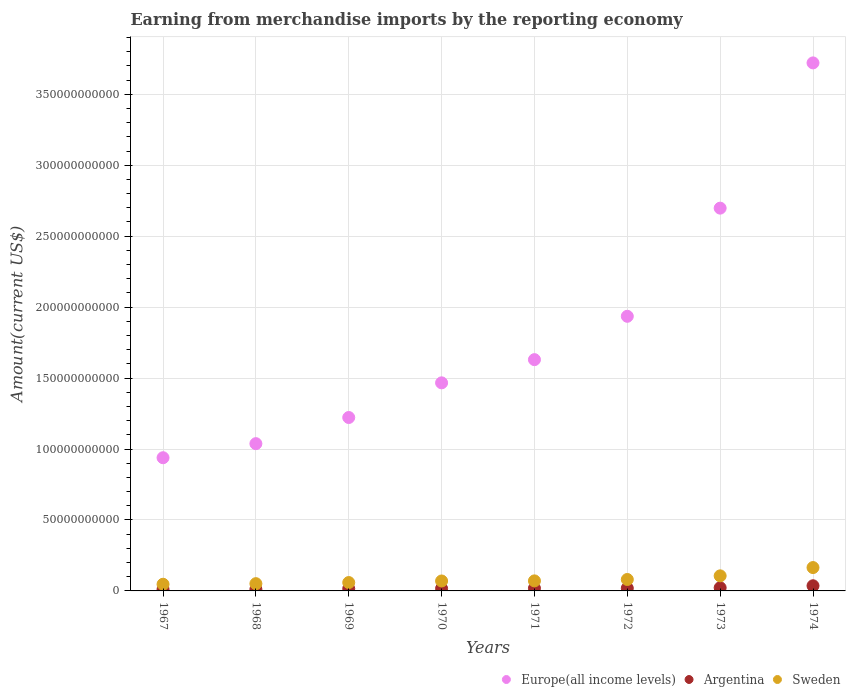Is the number of dotlines equal to the number of legend labels?
Your response must be concise. Yes. What is the amount earned from merchandise imports in Argentina in 1973?
Ensure brevity in your answer.  2.24e+09. Across all years, what is the maximum amount earned from merchandise imports in Europe(all income levels)?
Your response must be concise. 3.72e+11. Across all years, what is the minimum amount earned from merchandise imports in Europe(all income levels)?
Offer a terse response. 9.39e+1. In which year was the amount earned from merchandise imports in Sweden maximum?
Give a very brief answer. 1974. In which year was the amount earned from merchandise imports in Europe(all income levels) minimum?
Offer a terse response. 1967. What is the total amount earned from merchandise imports in Sweden in the graph?
Provide a short and direct response. 6.49e+1. What is the difference between the amount earned from merchandise imports in Sweden in 1967 and that in 1969?
Give a very brief answer. -1.21e+09. What is the difference between the amount earned from merchandise imports in Sweden in 1967 and the amount earned from merchandise imports in Europe(all income levels) in 1974?
Your answer should be very brief. -3.67e+11. What is the average amount earned from merchandise imports in Sweden per year?
Offer a very short reply. 8.12e+09. In the year 1970, what is the difference between the amount earned from merchandise imports in Sweden and amount earned from merchandise imports in Argentina?
Give a very brief answer. 5.32e+09. In how many years, is the amount earned from merchandise imports in Europe(all income levels) greater than 110000000000 US$?
Keep it short and to the point. 6. What is the ratio of the amount earned from merchandise imports in Europe(all income levels) in 1973 to that in 1974?
Offer a very short reply. 0.72. Is the difference between the amount earned from merchandise imports in Sweden in 1970 and 1973 greater than the difference between the amount earned from merchandise imports in Argentina in 1970 and 1973?
Provide a short and direct response. No. What is the difference between the highest and the second highest amount earned from merchandise imports in Sweden?
Make the answer very short. 5.83e+09. What is the difference between the highest and the lowest amount earned from merchandise imports in Sweden?
Your answer should be compact. 1.18e+1. In how many years, is the amount earned from merchandise imports in Sweden greater than the average amount earned from merchandise imports in Sweden taken over all years?
Give a very brief answer. 2. Is the sum of the amount earned from merchandise imports in Europe(all income levels) in 1970 and 1972 greater than the maximum amount earned from merchandise imports in Sweden across all years?
Provide a succinct answer. Yes. Is it the case that in every year, the sum of the amount earned from merchandise imports in Argentina and amount earned from merchandise imports in Europe(all income levels)  is greater than the amount earned from merchandise imports in Sweden?
Your answer should be compact. Yes. Is the amount earned from merchandise imports in Europe(all income levels) strictly less than the amount earned from merchandise imports in Sweden over the years?
Your answer should be very brief. No. How many dotlines are there?
Give a very brief answer. 3. How many years are there in the graph?
Provide a short and direct response. 8. Does the graph contain any zero values?
Give a very brief answer. No. Does the graph contain grids?
Your answer should be very brief. Yes. Where does the legend appear in the graph?
Your answer should be very brief. Bottom right. How are the legend labels stacked?
Keep it short and to the point. Horizontal. What is the title of the graph?
Keep it short and to the point. Earning from merchandise imports by the reporting economy. What is the label or title of the Y-axis?
Your answer should be very brief. Amount(current US$). What is the Amount(current US$) in Europe(all income levels) in 1967?
Offer a very short reply. 9.39e+1. What is the Amount(current US$) in Argentina in 1967?
Offer a terse response. 1.10e+09. What is the Amount(current US$) in Sweden in 1967?
Keep it short and to the point. 4.70e+09. What is the Amount(current US$) in Europe(all income levels) in 1968?
Make the answer very short. 1.04e+11. What is the Amount(current US$) in Argentina in 1968?
Provide a succinct answer. 1.17e+09. What is the Amount(current US$) in Sweden in 1968?
Ensure brevity in your answer.  5.12e+09. What is the Amount(current US$) in Europe(all income levels) in 1969?
Your answer should be compact. 1.22e+11. What is the Amount(current US$) of Argentina in 1969?
Provide a short and direct response. 1.58e+09. What is the Amount(current US$) of Sweden in 1969?
Your answer should be compact. 5.90e+09. What is the Amount(current US$) in Europe(all income levels) in 1970?
Ensure brevity in your answer.  1.47e+11. What is the Amount(current US$) in Argentina in 1970?
Offer a terse response. 1.68e+09. What is the Amount(current US$) in Sweden in 1970?
Your answer should be very brief. 7.01e+09. What is the Amount(current US$) in Europe(all income levels) in 1971?
Offer a very short reply. 1.63e+11. What is the Amount(current US$) in Argentina in 1971?
Ensure brevity in your answer.  1.87e+09. What is the Amount(current US$) in Sweden in 1971?
Offer a very short reply. 7.08e+09. What is the Amount(current US$) of Europe(all income levels) in 1972?
Keep it short and to the point. 1.94e+11. What is the Amount(current US$) of Argentina in 1972?
Provide a succinct answer. 1.90e+09. What is the Amount(current US$) in Sweden in 1972?
Your answer should be compact. 8.06e+09. What is the Amount(current US$) of Europe(all income levels) in 1973?
Your answer should be compact. 2.70e+11. What is the Amount(current US$) of Argentina in 1973?
Your answer should be very brief. 2.24e+09. What is the Amount(current US$) in Sweden in 1973?
Provide a succinct answer. 1.06e+1. What is the Amount(current US$) in Europe(all income levels) in 1974?
Make the answer very short. 3.72e+11. What is the Amount(current US$) of Argentina in 1974?
Ensure brevity in your answer.  3.64e+09. What is the Amount(current US$) of Sweden in 1974?
Provide a short and direct response. 1.65e+1. Across all years, what is the maximum Amount(current US$) of Europe(all income levels)?
Your answer should be compact. 3.72e+11. Across all years, what is the maximum Amount(current US$) of Argentina?
Offer a very short reply. 3.64e+09. Across all years, what is the maximum Amount(current US$) of Sweden?
Provide a succinct answer. 1.65e+1. Across all years, what is the minimum Amount(current US$) in Europe(all income levels)?
Your response must be concise. 9.39e+1. Across all years, what is the minimum Amount(current US$) of Argentina?
Your response must be concise. 1.10e+09. Across all years, what is the minimum Amount(current US$) in Sweden?
Your answer should be very brief. 4.70e+09. What is the total Amount(current US$) in Europe(all income levels) in the graph?
Offer a terse response. 1.46e+12. What is the total Amount(current US$) of Argentina in the graph?
Give a very brief answer. 1.52e+1. What is the total Amount(current US$) in Sweden in the graph?
Make the answer very short. 6.49e+1. What is the difference between the Amount(current US$) in Europe(all income levels) in 1967 and that in 1968?
Provide a short and direct response. -9.92e+09. What is the difference between the Amount(current US$) of Argentina in 1967 and that in 1968?
Keep it short and to the point. -7.40e+07. What is the difference between the Amount(current US$) in Sweden in 1967 and that in 1968?
Your answer should be very brief. -4.19e+08. What is the difference between the Amount(current US$) in Europe(all income levels) in 1967 and that in 1969?
Make the answer very short. -2.83e+1. What is the difference between the Amount(current US$) in Argentina in 1967 and that in 1969?
Provide a succinct answer. -4.81e+08. What is the difference between the Amount(current US$) of Sweden in 1967 and that in 1969?
Offer a very short reply. -1.21e+09. What is the difference between the Amount(current US$) in Europe(all income levels) in 1967 and that in 1970?
Provide a short and direct response. -5.28e+1. What is the difference between the Amount(current US$) in Argentina in 1967 and that in 1970?
Provide a succinct answer. -5.89e+08. What is the difference between the Amount(current US$) in Sweden in 1967 and that in 1970?
Give a very brief answer. -2.31e+09. What is the difference between the Amount(current US$) of Europe(all income levels) in 1967 and that in 1971?
Offer a terse response. -6.91e+1. What is the difference between the Amount(current US$) of Argentina in 1967 and that in 1971?
Your answer should be very brief. -7.74e+08. What is the difference between the Amount(current US$) of Sweden in 1967 and that in 1971?
Provide a succinct answer. -2.38e+09. What is the difference between the Amount(current US$) of Europe(all income levels) in 1967 and that in 1972?
Offer a very short reply. -9.97e+1. What is the difference between the Amount(current US$) in Argentina in 1967 and that in 1972?
Ensure brevity in your answer.  -8.09e+08. What is the difference between the Amount(current US$) of Sweden in 1967 and that in 1972?
Make the answer very short. -3.36e+09. What is the difference between the Amount(current US$) in Europe(all income levels) in 1967 and that in 1973?
Your answer should be very brief. -1.76e+11. What is the difference between the Amount(current US$) in Argentina in 1967 and that in 1973?
Keep it short and to the point. -1.15e+09. What is the difference between the Amount(current US$) in Sweden in 1967 and that in 1973?
Ensure brevity in your answer.  -5.93e+09. What is the difference between the Amount(current US$) in Europe(all income levels) in 1967 and that in 1974?
Offer a very short reply. -2.78e+11. What is the difference between the Amount(current US$) of Argentina in 1967 and that in 1974?
Offer a terse response. -2.54e+09. What is the difference between the Amount(current US$) of Sweden in 1967 and that in 1974?
Offer a terse response. -1.18e+1. What is the difference between the Amount(current US$) of Europe(all income levels) in 1968 and that in 1969?
Offer a terse response. -1.84e+1. What is the difference between the Amount(current US$) in Argentina in 1968 and that in 1969?
Give a very brief answer. -4.07e+08. What is the difference between the Amount(current US$) in Sweden in 1968 and that in 1969?
Keep it short and to the point. -7.86e+08. What is the difference between the Amount(current US$) in Europe(all income levels) in 1968 and that in 1970?
Your answer should be compact. -4.29e+1. What is the difference between the Amount(current US$) in Argentina in 1968 and that in 1970?
Offer a very short reply. -5.15e+08. What is the difference between the Amount(current US$) in Sweden in 1968 and that in 1970?
Offer a very short reply. -1.89e+09. What is the difference between the Amount(current US$) of Europe(all income levels) in 1968 and that in 1971?
Your answer should be very brief. -5.92e+1. What is the difference between the Amount(current US$) of Argentina in 1968 and that in 1971?
Keep it short and to the point. -7.00e+08. What is the difference between the Amount(current US$) in Sweden in 1968 and that in 1971?
Keep it short and to the point. -1.96e+09. What is the difference between the Amount(current US$) in Europe(all income levels) in 1968 and that in 1972?
Your answer should be very brief. -8.98e+1. What is the difference between the Amount(current US$) in Argentina in 1968 and that in 1972?
Offer a terse response. -7.35e+08. What is the difference between the Amount(current US$) in Sweden in 1968 and that in 1972?
Offer a terse response. -2.94e+09. What is the difference between the Amount(current US$) in Europe(all income levels) in 1968 and that in 1973?
Make the answer very short. -1.66e+11. What is the difference between the Amount(current US$) of Argentina in 1968 and that in 1973?
Make the answer very short. -1.07e+09. What is the difference between the Amount(current US$) of Sweden in 1968 and that in 1973?
Offer a terse response. -5.51e+09. What is the difference between the Amount(current US$) in Europe(all income levels) in 1968 and that in 1974?
Your answer should be very brief. -2.68e+11. What is the difference between the Amount(current US$) in Argentina in 1968 and that in 1974?
Provide a short and direct response. -2.47e+09. What is the difference between the Amount(current US$) of Sweden in 1968 and that in 1974?
Provide a succinct answer. -1.13e+1. What is the difference between the Amount(current US$) of Europe(all income levels) in 1969 and that in 1970?
Ensure brevity in your answer.  -2.44e+1. What is the difference between the Amount(current US$) of Argentina in 1969 and that in 1970?
Provide a short and direct response. -1.08e+08. What is the difference between the Amount(current US$) in Sweden in 1969 and that in 1970?
Offer a terse response. -1.10e+09. What is the difference between the Amount(current US$) of Europe(all income levels) in 1969 and that in 1971?
Your answer should be compact. -4.08e+1. What is the difference between the Amount(current US$) of Argentina in 1969 and that in 1971?
Keep it short and to the point. -2.93e+08. What is the difference between the Amount(current US$) in Sweden in 1969 and that in 1971?
Provide a short and direct response. -1.17e+09. What is the difference between the Amount(current US$) in Europe(all income levels) in 1969 and that in 1972?
Provide a short and direct response. -7.13e+1. What is the difference between the Amount(current US$) of Argentina in 1969 and that in 1972?
Provide a short and direct response. -3.28e+08. What is the difference between the Amount(current US$) in Sweden in 1969 and that in 1972?
Your answer should be very brief. -2.16e+09. What is the difference between the Amount(current US$) of Europe(all income levels) in 1969 and that in 1973?
Ensure brevity in your answer.  -1.48e+11. What is the difference between the Amount(current US$) in Argentina in 1969 and that in 1973?
Ensure brevity in your answer.  -6.65e+08. What is the difference between the Amount(current US$) in Sweden in 1969 and that in 1973?
Provide a succinct answer. -4.72e+09. What is the difference between the Amount(current US$) in Europe(all income levels) in 1969 and that in 1974?
Your response must be concise. -2.50e+11. What is the difference between the Amount(current US$) of Argentina in 1969 and that in 1974?
Give a very brief answer. -2.06e+09. What is the difference between the Amount(current US$) of Sweden in 1969 and that in 1974?
Your answer should be compact. -1.06e+1. What is the difference between the Amount(current US$) of Europe(all income levels) in 1970 and that in 1971?
Your response must be concise. -1.64e+1. What is the difference between the Amount(current US$) of Argentina in 1970 and that in 1971?
Keep it short and to the point. -1.85e+08. What is the difference between the Amount(current US$) of Sweden in 1970 and that in 1971?
Give a very brief answer. -7.09e+07. What is the difference between the Amount(current US$) of Europe(all income levels) in 1970 and that in 1972?
Provide a short and direct response. -4.69e+1. What is the difference between the Amount(current US$) in Argentina in 1970 and that in 1972?
Your response must be concise. -2.20e+08. What is the difference between the Amount(current US$) of Sweden in 1970 and that in 1972?
Your response must be concise. -1.06e+09. What is the difference between the Amount(current US$) of Europe(all income levels) in 1970 and that in 1973?
Provide a short and direct response. -1.23e+11. What is the difference between the Amount(current US$) in Argentina in 1970 and that in 1973?
Provide a short and direct response. -5.57e+08. What is the difference between the Amount(current US$) of Sweden in 1970 and that in 1973?
Offer a terse response. -3.62e+09. What is the difference between the Amount(current US$) in Europe(all income levels) in 1970 and that in 1974?
Give a very brief answer. -2.25e+11. What is the difference between the Amount(current US$) of Argentina in 1970 and that in 1974?
Give a very brief answer. -1.95e+09. What is the difference between the Amount(current US$) of Sweden in 1970 and that in 1974?
Provide a short and direct response. -9.45e+09. What is the difference between the Amount(current US$) of Europe(all income levels) in 1971 and that in 1972?
Give a very brief answer. -3.05e+1. What is the difference between the Amount(current US$) in Argentina in 1971 and that in 1972?
Keep it short and to the point. -3.51e+07. What is the difference between the Amount(current US$) in Sweden in 1971 and that in 1972?
Make the answer very short. -9.86e+08. What is the difference between the Amount(current US$) in Europe(all income levels) in 1971 and that in 1973?
Your answer should be very brief. -1.07e+11. What is the difference between the Amount(current US$) in Argentina in 1971 and that in 1973?
Provide a short and direct response. -3.72e+08. What is the difference between the Amount(current US$) in Sweden in 1971 and that in 1973?
Provide a short and direct response. -3.55e+09. What is the difference between the Amount(current US$) of Europe(all income levels) in 1971 and that in 1974?
Make the answer very short. -2.09e+11. What is the difference between the Amount(current US$) in Argentina in 1971 and that in 1974?
Keep it short and to the point. -1.77e+09. What is the difference between the Amount(current US$) of Sweden in 1971 and that in 1974?
Offer a terse response. -9.38e+09. What is the difference between the Amount(current US$) in Europe(all income levels) in 1972 and that in 1973?
Offer a very short reply. -7.62e+1. What is the difference between the Amount(current US$) in Argentina in 1972 and that in 1973?
Your answer should be compact. -3.37e+08. What is the difference between the Amount(current US$) in Sweden in 1972 and that in 1973?
Offer a terse response. -2.56e+09. What is the difference between the Amount(current US$) of Europe(all income levels) in 1972 and that in 1974?
Your answer should be very brief. -1.79e+11. What is the difference between the Amount(current US$) in Argentina in 1972 and that in 1974?
Provide a succinct answer. -1.73e+09. What is the difference between the Amount(current US$) of Sweden in 1972 and that in 1974?
Provide a succinct answer. -8.39e+09. What is the difference between the Amount(current US$) in Europe(all income levels) in 1973 and that in 1974?
Provide a short and direct response. -1.02e+11. What is the difference between the Amount(current US$) of Argentina in 1973 and that in 1974?
Your response must be concise. -1.39e+09. What is the difference between the Amount(current US$) in Sweden in 1973 and that in 1974?
Give a very brief answer. -5.83e+09. What is the difference between the Amount(current US$) in Europe(all income levels) in 1967 and the Amount(current US$) in Argentina in 1968?
Keep it short and to the point. 9.27e+1. What is the difference between the Amount(current US$) of Europe(all income levels) in 1967 and the Amount(current US$) of Sweden in 1968?
Offer a terse response. 8.87e+1. What is the difference between the Amount(current US$) in Argentina in 1967 and the Amount(current US$) in Sweden in 1968?
Give a very brief answer. -4.02e+09. What is the difference between the Amount(current US$) in Europe(all income levels) in 1967 and the Amount(current US$) in Argentina in 1969?
Your answer should be compact. 9.23e+1. What is the difference between the Amount(current US$) of Europe(all income levels) in 1967 and the Amount(current US$) of Sweden in 1969?
Your answer should be compact. 8.80e+1. What is the difference between the Amount(current US$) of Argentina in 1967 and the Amount(current US$) of Sweden in 1969?
Your answer should be very brief. -4.81e+09. What is the difference between the Amount(current US$) of Europe(all income levels) in 1967 and the Amount(current US$) of Argentina in 1970?
Your response must be concise. 9.22e+1. What is the difference between the Amount(current US$) in Europe(all income levels) in 1967 and the Amount(current US$) in Sweden in 1970?
Offer a terse response. 8.69e+1. What is the difference between the Amount(current US$) in Argentina in 1967 and the Amount(current US$) in Sweden in 1970?
Provide a succinct answer. -5.91e+09. What is the difference between the Amount(current US$) in Europe(all income levels) in 1967 and the Amount(current US$) in Argentina in 1971?
Your answer should be compact. 9.20e+1. What is the difference between the Amount(current US$) of Europe(all income levels) in 1967 and the Amount(current US$) of Sweden in 1971?
Your answer should be compact. 8.68e+1. What is the difference between the Amount(current US$) of Argentina in 1967 and the Amount(current US$) of Sweden in 1971?
Your response must be concise. -5.98e+09. What is the difference between the Amount(current US$) in Europe(all income levels) in 1967 and the Amount(current US$) in Argentina in 1972?
Keep it short and to the point. 9.20e+1. What is the difference between the Amount(current US$) in Europe(all income levels) in 1967 and the Amount(current US$) in Sweden in 1972?
Your answer should be very brief. 8.58e+1. What is the difference between the Amount(current US$) of Argentina in 1967 and the Amount(current US$) of Sweden in 1972?
Ensure brevity in your answer.  -6.97e+09. What is the difference between the Amount(current US$) in Europe(all income levels) in 1967 and the Amount(current US$) in Argentina in 1973?
Provide a short and direct response. 9.16e+1. What is the difference between the Amount(current US$) in Europe(all income levels) in 1967 and the Amount(current US$) in Sweden in 1973?
Make the answer very short. 8.32e+1. What is the difference between the Amount(current US$) in Argentina in 1967 and the Amount(current US$) in Sweden in 1973?
Give a very brief answer. -9.53e+09. What is the difference between the Amount(current US$) in Europe(all income levels) in 1967 and the Amount(current US$) in Argentina in 1974?
Your answer should be very brief. 9.02e+1. What is the difference between the Amount(current US$) of Europe(all income levels) in 1967 and the Amount(current US$) of Sweden in 1974?
Make the answer very short. 7.74e+1. What is the difference between the Amount(current US$) in Argentina in 1967 and the Amount(current US$) in Sweden in 1974?
Provide a succinct answer. -1.54e+1. What is the difference between the Amount(current US$) of Europe(all income levels) in 1968 and the Amount(current US$) of Argentina in 1969?
Offer a very short reply. 1.02e+11. What is the difference between the Amount(current US$) in Europe(all income levels) in 1968 and the Amount(current US$) in Sweden in 1969?
Offer a very short reply. 9.79e+1. What is the difference between the Amount(current US$) of Argentina in 1968 and the Amount(current US$) of Sweden in 1969?
Ensure brevity in your answer.  -4.73e+09. What is the difference between the Amount(current US$) of Europe(all income levels) in 1968 and the Amount(current US$) of Argentina in 1970?
Your answer should be compact. 1.02e+11. What is the difference between the Amount(current US$) of Europe(all income levels) in 1968 and the Amount(current US$) of Sweden in 1970?
Give a very brief answer. 9.68e+1. What is the difference between the Amount(current US$) of Argentina in 1968 and the Amount(current US$) of Sweden in 1970?
Provide a succinct answer. -5.84e+09. What is the difference between the Amount(current US$) of Europe(all income levels) in 1968 and the Amount(current US$) of Argentina in 1971?
Ensure brevity in your answer.  1.02e+11. What is the difference between the Amount(current US$) of Europe(all income levels) in 1968 and the Amount(current US$) of Sweden in 1971?
Provide a short and direct response. 9.67e+1. What is the difference between the Amount(current US$) of Argentina in 1968 and the Amount(current US$) of Sweden in 1971?
Offer a terse response. -5.91e+09. What is the difference between the Amount(current US$) in Europe(all income levels) in 1968 and the Amount(current US$) in Argentina in 1972?
Offer a very short reply. 1.02e+11. What is the difference between the Amount(current US$) of Europe(all income levels) in 1968 and the Amount(current US$) of Sweden in 1972?
Keep it short and to the point. 9.57e+1. What is the difference between the Amount(current US$) of Argentina in 1968 and the Amount(current US$) of Sweden in 1972?
Offer a terse response. -6.89e+09. What is the difference between the Amount(current US$) in Europe(all income levels) in 1968 and the Amount(current US$) in Argentina in 1973?
Keep it short and to the point. 1.02e+11. What is the difference between the Amount(current US$) in Europe(all income levels) in 1968 and the Amount(current US$) in Sweden in 1973?
Ensure brevity in your answer.  9.32e+1. What is the difference between the Amount(current US$) in Argentina in 1968 and the Amount(current US$) in Sweden in 1973?
Provide a succinct answer. -9.46e+09. What is the difference between the Amount(current US$) in Europe(all income levels) in 1968 and the Amount(current US$) in Argentina in 1974?
Offer a terse response. 1.00e+11. What is the difference between the Amount(current US$) in Europe(all income levels) in 1968 and the Amount(current US$) in Sweden in 1974?
Keep it short and to the point. 8.73e+1. What is the difference between the Amount(current US$) in Argentina in 1968 and the Amount(current US$) in Sweden in 1974?
Keep it short and to the point. -1.53e+1. What is the difference between the Amount(current US$) in Europe(all income levels) in 1969 and the Amount(current US$) in Argentina in 1970?
Offer a very short reply. 1.21e+11. What is the difference between the Amount(current US$) in Europe(all income levels) in 1969 and the Amount(current US$) in Sweden in 1970?
Ensure brevity in your answer.  1.15e+11. What is the difference between the Amount(current US$) of Argentina in 1969 and the Amount(current US$) of Sweden in 1970?
Make the answer very short. -5.43e+09. What is the difference between the Amount(current US$) of Europe(all income levels) in 1969 and the Amount(current US$) of Argentina in 1971?
Provide a succinct answer. 1.20e+11. What is the difference between the Amount(current US$) in Europe(all income levels) in 1969 and the Amount(current US$) in Sweden in 1971?
Make the answer very short. 1.15e+11. What is the difference between the Amount(current US$) in Argentina in 1969 and the Amount(current US$) in Sweden in 1971?
Make the answer very short. -5.50e+09. What is the difference between the Amount(current US$) in Europe(all income levels) in 1969 and the Amount(current US$) in Argentina in 1972?
Your answer should be compact. 1.20e+11. What is the difference between the Amount(current US$) of Europe(all income levels) in 1969 and the Amount(current US$) of Sweden in 1972?
Give a very brief answer. 1.14e+11. What is the difference between the Amount(current US$) of Argentina in 1969 and the Amount(current US$) of Sweden in 1972?
Make the answer very short. -6.49e+09. What is the difference between the Amount(current US$) in Europe(all income levels) in 1969 and the Amount(current US$) in Argentina in 1973?
Your answer should be very brief. 1.20e+11. What is the difference between the Amount(current US$) in Europe(all income levels) in 1969 and the Amount(current US$) in Sweden in 1973?
Provide a succinct answer. 1.12e+11. What is the difference between the Amount(current US$) in Argentina in 1969 and the Amount(current US$) in Sweden in 1973?
Make the answer very short. -9.05e+09. What is the difference between the Amount(current US$) in Europe(all income levels) in 1969 and the Amount(current US$) in Argentina in 1974?
Make the answer very short. 1.19e+11. What is the difference between the Amount(current US$) in Europe(all income levels) in 1969 and the Amount(current US$) in Sweden in 1974?
Make the answer very short. 1.06e+11. What is the difference between the Amount(current US$) of Argentina in 1969 and the Amount(current US$) of Sweden in 1974?
Your response must be concise. -1.49e+1. What is the difference between the Amount(current US$) in Europe(all income levels) in 1970 and the Amount(current US$) in Argentina in 1971?
Ensure brevity in your answer.  1.45e+11. What is the difference between the Amount(current US$) of Europe(all income levels) in 1970 and the Amount(current US$) of Sweden in 1971?
Offer a terse response. 1.40e+11. What is the difference between the Amount(current US$) of Argentina in 1970 and the Amount(current US$) of Sweden in 1971?
Offer a terse response. -5.39e+09. What is the difference between the Amount(current US$) in Europe(all income levels) in 1970 and the Amount(current US$) in Argentina in 1972?
Make the answer very short. 1.45e+11. What is the difference between the Amount(current US$) of Europe(all income levels) in 1970 and the Amount(current US$) of Sweden in 1972?
Offer a terse response. 1.39e+11. What is the difference between the Amount(current US$) of Argentina in 1970 and the Amount(current US$) of Sweden in 1972?
Offer a very short reply. -6.38e+09. What is the difference between the Amount(current US$) of Europe(all income levels) in 1970 and the Amount(current US$) of Argentina in 1973?
Offer a terse response. 1.44e+11. What is the difference between the Amount(current US$) in Europe(all income levels) in 1970 and the Amount(current US$) in Sweden in 1973?
Your answer should be compact. 1.36e+11. What is the difference between the Amount(current US$) of Argentina in 1970 and the Amount(current US$) of Sweden in 1973?
Give a very brief answer. -8.94e+09. What is the difference between the Amount(current US$) of Europe(all income levels) in 1970 and the Amount(current US$) of Argentina in 1974?
Your answer should be very brief. 1.43e+11. What is the difference between the Amount(current US$) of Europe(all income levels) in 1970 and the Amount(current US$) of Sweden in 1974?
Give a very brief answer. 1.30e+11. What is the difference between the Amount(current US$) in Argentina in 1970 and the Amount(current US$) in Sweden in 1974?
Provide a short and direct response. -1.48e+1. What is the difference between the Amount(current US$) of Europe(all income levels) in 1971 and the Amount(current US$) of Argentina in 1972?
Keep it short and to the point. 1.61e+11. What is the difference between the Amount(current US$) of Europe(all income levels) in 1971 and the Amount(current US$) of Sweden in 1972?
Provide a succinct answer. 1.55e+11. What is the difference between the Amount(current US$) of Argentina in 1971 and the Amount(current US$) of Sweden in 1972?
Offer a terse response. -6.19e+09. What is the difference between the Amount(current US$) of Europe(all income levels) in 1971 and the Amount(current US$) of Argentina in 1973?
Offer a terse response. 1.61e+11. What is the difference between the Amount(current US$) in Europe(all income levels) in 1971 and the Amount(current US$) in Sweden in 1973?
Give a very brief answer. 1.52e+11. What is the difference between the Amount(current US$) in Argentina in 1971 and the Amount(current US$) in Sweden in 1973?
Your response must be concise. -8.76e+09. What is the difference between the Amount(current US$) of Europe(all income levels) in 1971 and the Amount(current US$) of Argentina in 1974?
Your answer should be very brief. 1.59e+11. What is the difference between the Amount(current US$) in Europe(all income levels) in 1971 and the Amount(current US$) in Sweden in 1974?
Provide a succinct answer. 1.47e+11. What is the difference between the Amount(current US$) of Argentina in 1971 and the Amount(current US$) of Sweden in 1974?
Keep it short and to the point. -1.46e+1. What is the difference between the Amount(current US$) in Europe(all income levels) in 1972 and the Amount(current US$) in Argentina in 1973?
Your response must be concise. 1.91e+11. What is the difference between the Amount(current US$) in Europe(all income levels) in 1972 and the Amount(current US$) in Sweden in 1973?
Your answer should be compact. 1.83e+11. What is the difference between the Amount(current US$) of Argentina in 1972 and the Amount(current US$) of Sweden in 1973?
Give a very brief answer. -8.72e+09. What is the difference between the Amount(current US$) of Europe(all income levels) in 1972 and the Amount(current US$) of Argentina in 1974?
Give a very brief answer. 1.90e+11. What is the difference between the Amount(current US$) in Europe(all income levels) in 1972 and the Amount(current US$) in Sweden in 1974?
Your answer should be compact. 1.77e+11. What is the difference between the Amount(current US$) in Argentina in 1972 and the Amount(current US$) in Sweden in 1974?
Keep it short and to the point. -1.46e+1. What is the difference between the Amount(current US$) in Europe(all income levels) in 1973 and the Amount(current US$) in Argentina in 1974?
Your answer should be very brief. 2.66e+11. What is the difference between the Amount(current US$) of Europe(all income levels) in 1973 and the Amount(current US$) of Sweden in 1974?
Provide a short and direct response. 2.53e+11. What is the difference between the Amount(current US$) in Argentina in 1973 and the Amount(current US$) in Sweden in 1974?
Your response must be concise. -1.42e+1. What is the average Amount(current US$) of Europe(all income levels) per year?
Provide a short and direct response. 1.83e+11. What is the average Amount(current US$) in Argentina per year?
Your response must be concise. 1.90e+09. What is the average Amount(current US$) in Sweden per year?
Your response must be concise. 8.12e+09. In the year 1967, what is the difference between the Amount(current US$) of Europe(all income levels) and Amount(current US$) of Argentina?
Provide a short and direct response. 9.28e+1. In the year 1967, what is the difference between the Amount(current US$) of Europe(all income levels) and Amount(current US$) of Sweden?
Your answer should be compact. 8.92e+1. In the year 1967, what is the difference between the Amount(current US$) in Argentina and Amount(current US$) in Sweden?
Keep it short and to the point. -3.60e+09. In the year 1968, what is the difference between the Amount(current US$) of Europe(all income levels) and Amount(current US$) of Argentina?
Provide a short and direct response. 1.03e+11. In the year 1968, what is the difference between the Amount(current US$) of Europe(all income levels) and Amount(current US$) of Sweden?
Provide a short and direct response. 9.87e+1. In the year 1968, what is the difference between the Amount(current US$) of Argentina and Amount(current US$) of Sweden?
Your answer should be compact. -3.95e+09. In the year 1969, what is the difference between the Amount(current US$) in Europe(all income levels) and Amount(current US$) in Argentina?
Give a very brief answer. 1.21e+11. In the year 1969, what is the difference between the Amount(current US$) of Europe(all income levels) and Amount(current US$) of Sweden?
Your answer should be very brief. 1.16e+11. In the year 1969, what is the difference between the Amount(current US$) in Argentina and Amount(current US$) in Sweden?
Ensure brevity in your answer.  -4.33e+09. In the year 1970, what is the difference between the Amount(current US$) of Europe(all income levels) and Amount(current US$) of Argentina?
Your answer should be very brief. 1.45e+11. In the year 1970, what is the difference between the Amount(current US$) in Europe(all income levels) and Amount(current US$) in Sweden?
Keep it short and to the point. 1.40e+11. In the year 1970, what is the difference between the Amount(current US$) in Argentina and Amount(current US$) in Sweden?
Offer a terse response. -5.32e+09. In the year 1971, what is the difference between the Amount(current US$) in Europe(all income levels) and Amount(current US$) in Argentina?
Keep it short and to the point. 1.61e+11. In the year 1971, what is the difference between the Amount(current US$) of Europe(all income levels) and Amount(current US$) of Sweden?
Give a very brief answer. 1.56e+11. In the year 1971, what is the difference between the Amount(current US$) of Argentina and Amount(current US$) of Sweden?
Offer a very short reply. -5.21e+09. In the year 1972, what is the difference between the Amount(current US$) in Europe(all income levels) and Amount(current US$) in Argentina?
Your answer should be very brief. 1.92e+11. In the year 1972, what is the difference between the Amount(current US$) in Europe(all income levels) and Amount(current US$) in Sweden?
Provide a succinct answer. 1.85e+11. In the year 1972, what is the difference between the Amount(current US$) in Argentina and Amount(current US$) in Sweden?
Provide a short and direct response. -6.16e+09. In the year 1973, what is the difference between the Amount(current US$) of Europe(all income levels) and Amount(current US$) of Argentina?
Give a very brief answer. 2.68e+11. In the year 1973, what is the difference between the Amount(current US$) of Europe(all income levels) and Amount(current US$) of Sweden?
Offer a terse response. 2.59e+11. In the year 1973, what is the difference between the Amount(current US$) of Argentina and Amount(current US$) of Sweden?
Give a very brief answer. -8.38e+09. In the year 1974, what is the difference between the Amount(current US$) of Europe(all income levels) and Amount(current US$) of Argentina?
Offer a terse response. 3.68e+11. In the year 1974, what is the difference between the Amount(current US$) in Europe(all income levels) and Amount(current US$) in Sweden?
Your response must be concise. 3.56e+11. In the year 1974, what is the difference between the Amount(current US$) in Argentina and Amount(current US$) in Sweden?
Your answer should be very brief. -1.28e+1. What is the ratio of the Amount(current US$) of Europe(all income levels) in 1967 to that in 1968?
Provide a succinct answer. 0.9. What is the ratio of the Amount(current US$) of Argentina in 1967 to that in 1968?
Your answer should be very brief. 0.94. What is the ratio of the Amount(current US$) of Sweden in 1967 to that in 1968?
Make the answer very short. 0.92. What is the ratio of the Amount(current US$) in Europe(all income levels) in 1967 to that in 1969?
Offer a very short reply. 0.77. What is the ratio of the Amount(current US$) in Argentina in 1967 to that in 1969?
Offer a very short reply. 0.7. What is the ratio of the Amount(current US$) of Sweden in 1967 to that in 1969?
Provide a short and direct response. 0.8. What is the ratio of the Amount(current US$) in Europe(all income levels) in 1967 to that in 1970?
Offer a very short reply. 0.64. What is the ratio of the Amount(current US$) of Argentina in 1967 to that in 1970?
Make the answer very short. 0.65. What is the ratio of the Amount(current US$) in Sweden in 1967 to that in 1970?
Offer a very short reply. 0.67. What is the ratio of the Amount(current US$) of Europe(all income levels) in 1967 to that in 1971?
Offer a very short reply. 0.58. What is the ratio of the Amount(current US$) in Argentina in 1967 to that in 1971?
Your answer should be compact. 0.59. What is the ratio of the Amount(current US$) of Sweden in 1967 to that in 1971?
Your answer should be very brief. 0.66. What is the ratio of the Amount(current US$) in Europe(all income levels) in 1967 to that in 1972?
Make the answer very short. 0.48. What is the ratio of the Amount(current US$) in Argentina in 1967 to that in 1972?
Your response must be concise. 0.58. What is the ratio of the Amount(current US$) in Sweden in 1967 to that in 1972?
Your response must be concise. 0.58. What is the ratio of the Amount(current US$) in Europe(all income levels) in 1967 to that in 1973?
Provide a short and direct response. 0.35. What is the ratio of the Amount(current US$) in Argentina in 1967 to that in 1973?
Your answer should be very brief. 0.49. What is the ratio of the Amount(current US$) of Sweden in 1967 to that in 1973?
Your answer should be very brief. 0.44. What is the ratio of the Amount(current US$) in Europe(all income levels) in 1967 to that in 1974?
Give a very brief answer. 0.25. What is the ratio of the Amount(current US$) of Argentina in 1967 to that in 1974?
Make the answer very short. 0.3. What is the ratio of the Amount(current US$) of Sweden in 1967 to that in 1974?
Make the answer very short. 0.29. What is the ratio of the Amount(current US$) of Europe(all income levels) in 1968 to that in 1969?
Provide a succinct answer. 0.85. What is the ratio of the Amount(current US$) of Argentina in 1968 to that in 1969?
Your answer should be very brief. 0.74. What is the ratio of the Amount(current US$) of Sweden in 1968 to that in 1969?
Provide a short and direct response. 0.87. What is the ratio of the Amount(current US$) of Europe(all income levels) in 1968 to that in 1970?
Provide a succinct answer. 0.71. What is the ratio of the Amount(current US$) in Argentina in 1968 to that in 1970?
Offer a terse response. 0.69. What is the ratio of the Amount(current US$) of Sweden in 1968 to that in 1970?
Keep it short and to the point. 0.73. What is the ratio of the Amount(current US$) of Europe(all income levels) in 1968 to that in 1971?
Give a very brief answer. 0.64. What is the ratio of the Amount(current US$) of Argentina in 1968 to that in 1971?
Offer a very short reply. 0.63. What is the ratio of the Amount(current US$) of Sweden in 1968 to that in 1971?
Provide a succinct answer. 0.72. What is the ratio of the Amount(current US$) in Europe(all income levels) in 1968 to that in 1972?
Your answer should be very brief. 0.54. What is the ratio of the Amount(current US$) of Argentina in 1968 to that in 1972?
Make the answer very short. 0.61. What is the ratio of the Amount(current US$) in Sweden in 1968 to that in 1972?
Offer a very short reply. 0.63. What is the ratio of the Amount(current US$) in Europe(all income levels) in 1968 to that in 1973?
Make the answer very short. 0.38. What is the ratio of the Amount(current US$) in Argentina in 1968 to that in 1973?
Your answer should be very brief. 0.52. What is the ratio of the Amount(current US$) in Sweden in 1968 to that in 1973?
Offer a terse response. 0.48. What is the ratio of the Amount(current US$) of Europe(all income levels) in 1968 to that in 1974?
Provide a succinct answer. 0.28. What is the ratio of the Amount(current US$) of Argentina in 1968 to that in 1974?
Give a very brief answer. 0.32. What is the ratio of the Amount(current US$) in Sweden in 1968 to that in 1974?
Provide a short and direct response. 0.31. What is the ratio of the Amount(current US$) in Europe(all income levels) in 1969 to that in 1970?
Your response must be concise. 0.83. What is the ratio of the Amount(current US$) in Argentina in 1969 to that in 1970?
Keep it short and to the point. 0.94. What is the ratio of the Amount(current US$) of Sweden in 1969 to that in 1970?
Make the answer very short. 0.84. What is the ratio of the Amount(current US$) in Europe(all income levels) in 1969 to that in 1971?
Offer a very short reply. 0.75. What is the ratio of the Amount(current US$) of Argentina in 1969 to that in 1971?
Provide a short and direct response. 0.84. What is the ratio of the Amount(current US$) in Sweden in 1969 to that in 1971?
Provide a succinct answer. 0.83. What is the ratio of the Amount(current US$) in Europe(all income levels) in 1969 to that in 1972?
Give a very brief answer. 0.63. What is the ratio of the Amount(current US$) of Argentina in 1969 to that in 1972?
Your answer should be compact. 0.83. What is the ratio of the Amount(current US$) of Sweden in 1969 to that in 1972?
Your answer should be compact. 0.73. What is the ratio of the Amount(current US$) of Europe(all income levels) in 1969 to that in 1973?
Ensure brevity in your answer.  0.45. What is the ratio of the Amount(current US$) in Argentina in 1969 to that in 1973?
Offer a very short reply. 0.7. What is the ratio of the Amount(current US$) in Sweden in 1969 to that in 1973?
Provide a succinct answer. 0.56. What is the ratio of the Amount(current US$) in Europe(all income levels) in 1969 to that in 1974?
Your response must be concise. 0.33. What is the ratio of the Amount(current US$) of Argentina in 1969 to that in 1974?
Give a very brief answer. 0.43. What is the ratio of the Amount(current US$) of Sweden in 1969 to that in 1974?
Your answer should be compact. 0.36. What is the ratio of the Amount(current US$) in Europe(all income levels) in 1970 to that in 1971?
Offer a very short reply. 0.9. What is the ratio of the Amount(current US$) of Argentina in 1970 to that in 1971?
Provide a short and direct response. 0.9. What is the ratio of the Amount(current US$) of Europe(all income levels) in 1970 to that in 1972?
Ensure brevity in your answer.  0.76. What is the ratio of the Amount(current US$) of Argentina in 1970 to that in 1972?
Provide a succinct answer. 0.88. What is the ratio of the Amount(current US$) of Sweden in 1970 to that in 1972?
Your answer should be compact. 0.87. What is the ratio of the Amount(current US$) in Europe(all income levels) in 1970 to that in 1973?
Give a very brief answer. 0.54. What is the ratio of the Amount(current US$) of Argentina in 1970 to that in 1973?
Ensure brevity in your answer.  0.75. What is the ratio of the Amount(current US$) in Sweden in 1970 to that in 1973?
Make the answer very short. 0.66. What is the ratio of the Amount(current US$) in Europe(all income levels) in 1970 to that in 1974?
Give a very brief answer. 0.39. What is the ratio of the Amount(current US$) of Argentina in 1970 to that in 1974?
Keep it short and to the point. 0.46. What is the ratio of the Amount(current US$) in Sweden in 1970 to that in 1974?
Provide a short and direct response. 0.43. What is the ratio of the Amount(current US$) of Europe(all income levels) in 1971 to that in 1972?
Ensure brevity in your answer.  0.84. What is the ratio of the Amount(current US$) of Argentina in 1971 to that in 1972?
Offer a very short reply. 0.98. What is the ratio of the Amount(current US$) in Sweden in 1971 to that in 1972?
Provide a succinct answer. 0.88. What is the ratio of the Amount(current US$) of Europe(all income levels) in 1971 to that in 1973?
Your response must be concise. 0.6. What is the ratio of the Amount(current US$) of Argentina in 1971 to that in 1973?
Offer a very short reply. 0.83. What is the ratio of the Amount(current US$) of Sweden in 1971 to that in 1973?
Your answer should be very brief. 0.67. What is the ratio of the Amount(current US$) of Europe(all income levels) in 1971 to that in 1974?
Offer a very short reply. 0.44. What is the ratio of the Amount(current US$) in Argentina in 1971 to that in 1974?
Keep it short and to the point. 0.51. What is the ratio of the Amount(current US$) of Sweden in 1971 to that in 1974?
Provide a short and direct response. 0.43. What is the ratio of the Amount(current US$) of Europe(all income levels) in 1972 to that in 1973?
Give a very brief answer. 0.72. What is the ratio of the Amount(current US$) in Argentina in 1972 to that in 1973?
Make the answer very short. 0.85. What is the ratio of the Amount(current US$) in Sweden in 1972 to that in 1973?
Offer a terse response. 0.76. What is the ratio of the Amount(current US$) of Europe(all income levels) in 1972 to that in 1974?
Provide a succinct answer. 0.52. What is the ratio of the Amount(current US$) of Argentina in 1972 to that in 1974?
Make the answer very short. 0.52. What is the ratio of the Amount(current US$) of Sweden in 1972 to that in 1974?
Provide a succinct answer. 0.49. What is the ratio of the Amount(current US$) in Europe(all income levels) in 1973 to that in 1974?
Offer a very short reply. 0.72. What is the ratio of the Amount(current US$) in Argentina in 1973 to that in 1974?
Offer a terse response. 0.62. What is the ratio of the Amount(current US$) of Sweden in 1973 to that in 1974?
Your response must be concise. 0.65. What is the difference between the highest and the second highest Amount(current US$) of Europe(all income levels)?
Make the answer very short. 1.02e+11. What is the difference between the highest and the second highest Amount(current US$) in Argentina?
Offer a very short reply. 1.39e+09. What is the difference between the highest and the second highest Amount(current US$) in Sweden?
Make the answer very short. 5.83e+09. What is the difference between the highest and the lowest Amount(current US$) in Europe(all income levels)?
Offer a very short reply. 2.78e+11. What is the difference between the highest and the lowest Amount(current US$) in Argentina?
Give a very brief answer. 2.54e+09. What is the difference between the highest and the lowest Amount(current US$) of Sweden?
Offer a very short reply. 1.18e+1. 